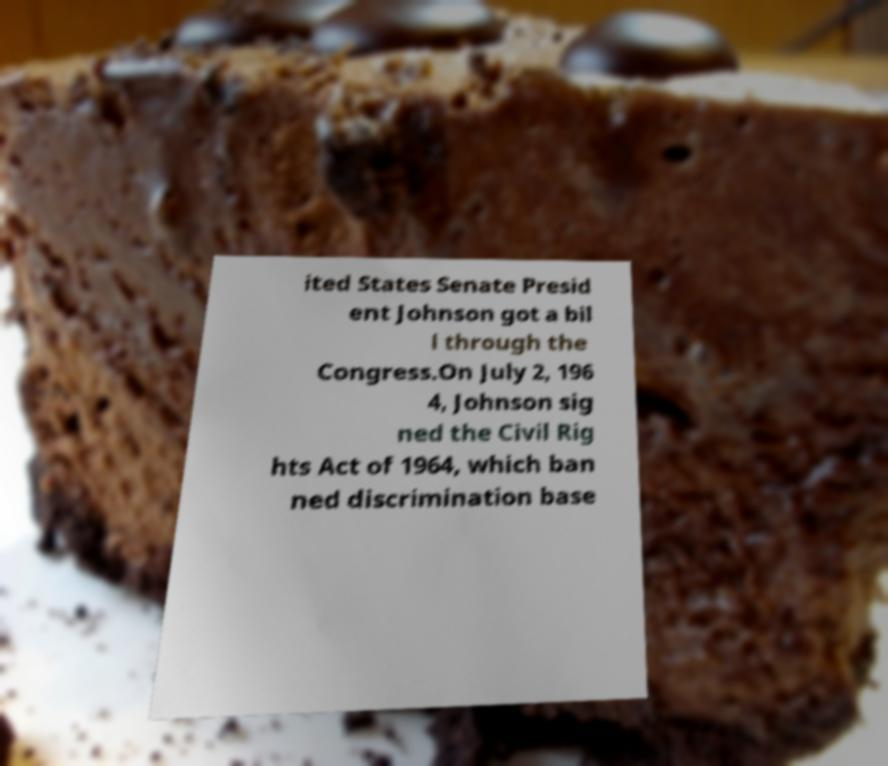There's text embedded in this image that I need extracted. Can you transcribe it verbatim? ited States Senate Presid ent Johnson got a bil l through the Congress.On July 2, 196 4, Johnson sig ned the Civil Rig hts Act of 1964, which ban ned discrimination base 